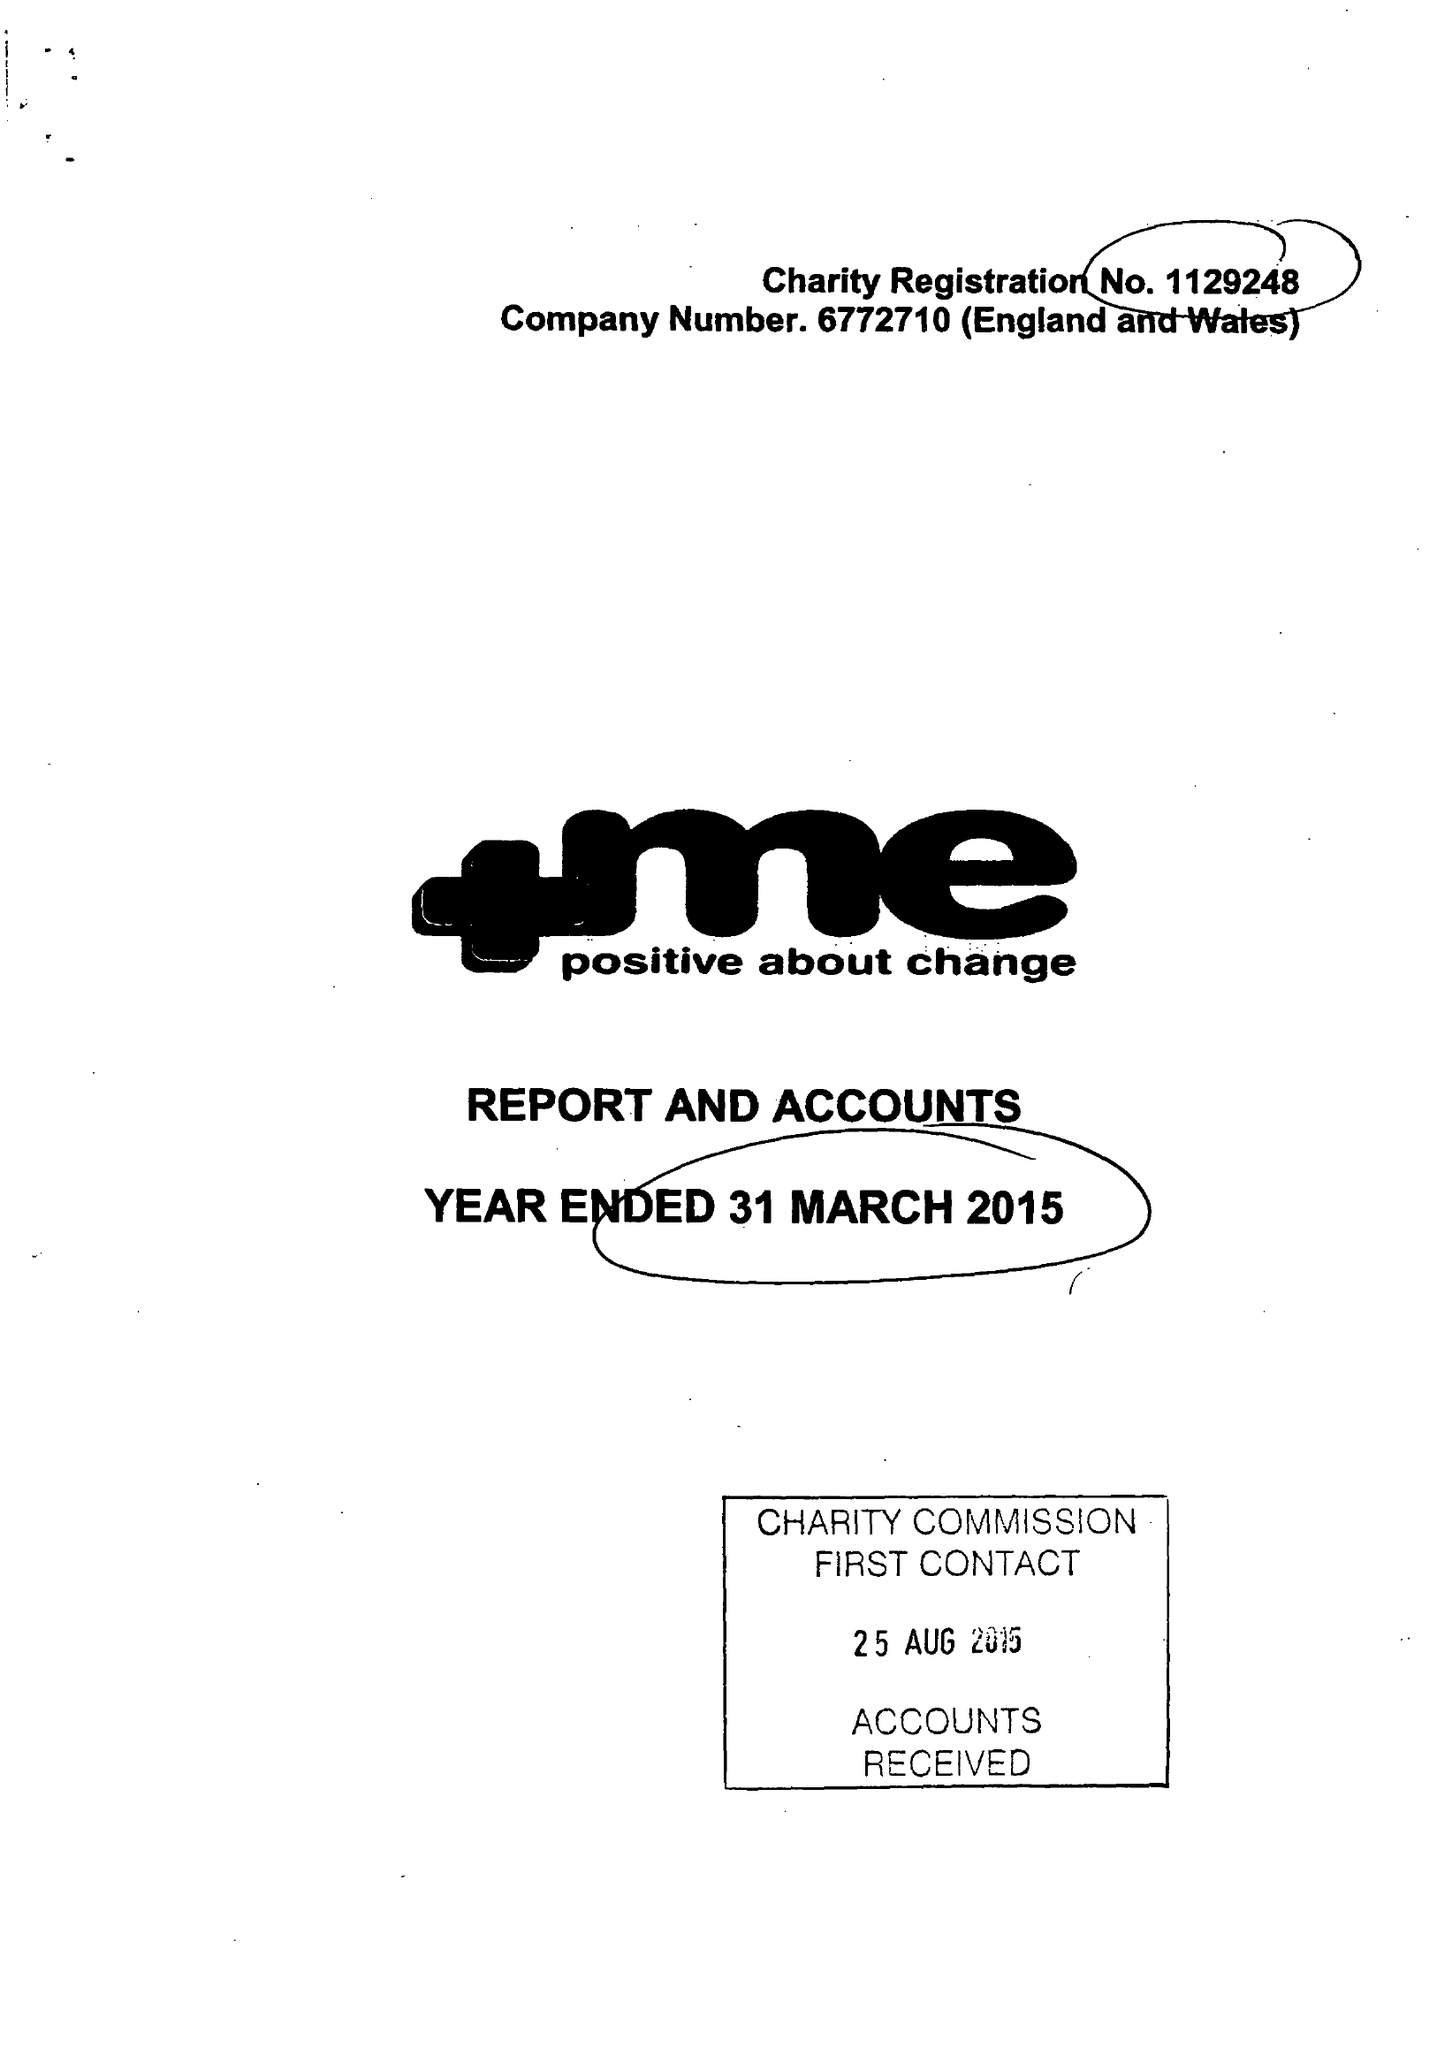What is the value for the spending_annually_in_british_pounds?
Answer the question using a single word or phrase. 92133.00 